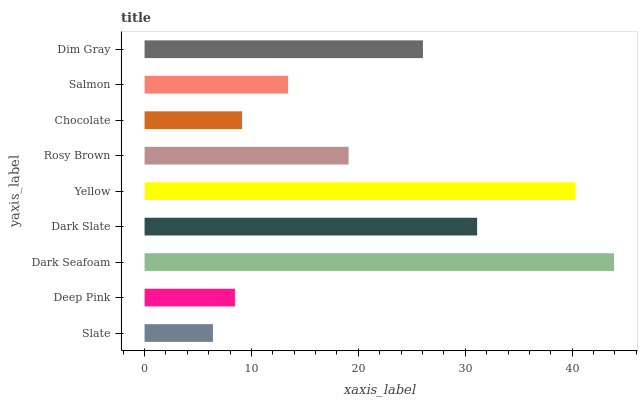Is Slate the minimum?
Answer yes or no. Yes. Is Dark Seafoam the maximum?
Answer yes or no. Yes. Is Deep Pink the minimum?
Answer yes or no. No. Is Deep Pink the maximum?
Answer yes or no. No. Is Deep Pink greater than Slate?
Answer yes or no. Yes. Is Slate less than Deep Pink?
Answer yes or no. Yes. Is Slate greater than Deep Pink?
Answer yes or no. No. Is Deep Pink less than Slate?
Answer yes or no. No. Is Rosy Brown the high median?
Answer yes or no. Yes. Is Rosy Brown the low median?
Answer yes or no. Yes. Is Dim Gray the high median?
Answer yes or no. No. Is Slate the low median?
Answer yes or no. No. 